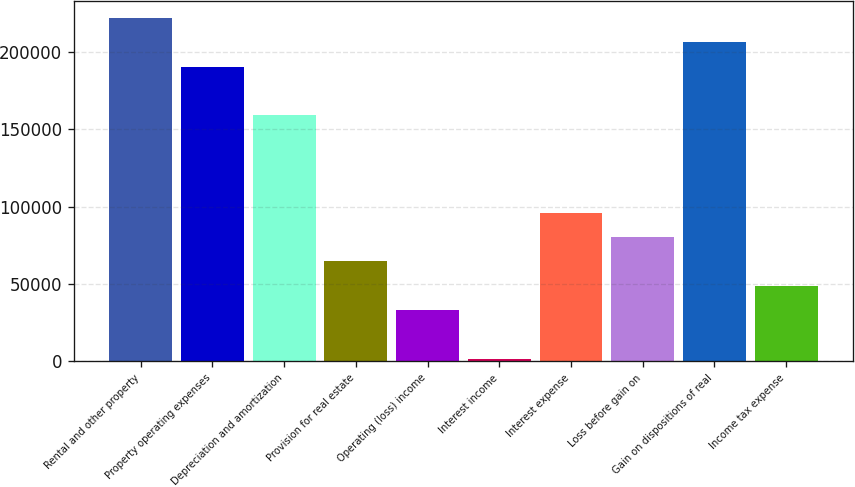Convert chart. <chart><loc_0><loc_0><loc_500><loc_500><bar_chart><fcel>Rental and other property<fcel>Property operating expenses<fcel>Depreciation and amortization<fcel>Provision for real estate<fcel>Operating (loss) income<fcel>Interest income<fcel>Interest expense<fcel>Loss before gain on<fcel>Gain on dispositions of real<fcel>Income tax expense<nl><fcel>222068<fcel>190563<fcel>159058<fcel>64543.6<fcel>33038.8<fcel>1534<fcel>96048.4<fcel>80296<fcel>206315<fcel>48791.2<nl></chart> 